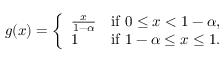<formula> <loc_0><loc_0><loc_500><loc_500>g ( x ) = { \left \{ \begin{array} { l l } { { \frac { x } { 1 - \alpha } } } & { { i f } 0 \leq x < 1 - \alpha , } \\ { 1 } & { { i f } 1 - \alpha \leq x \leq 1 . } \end{array} }</formula> 